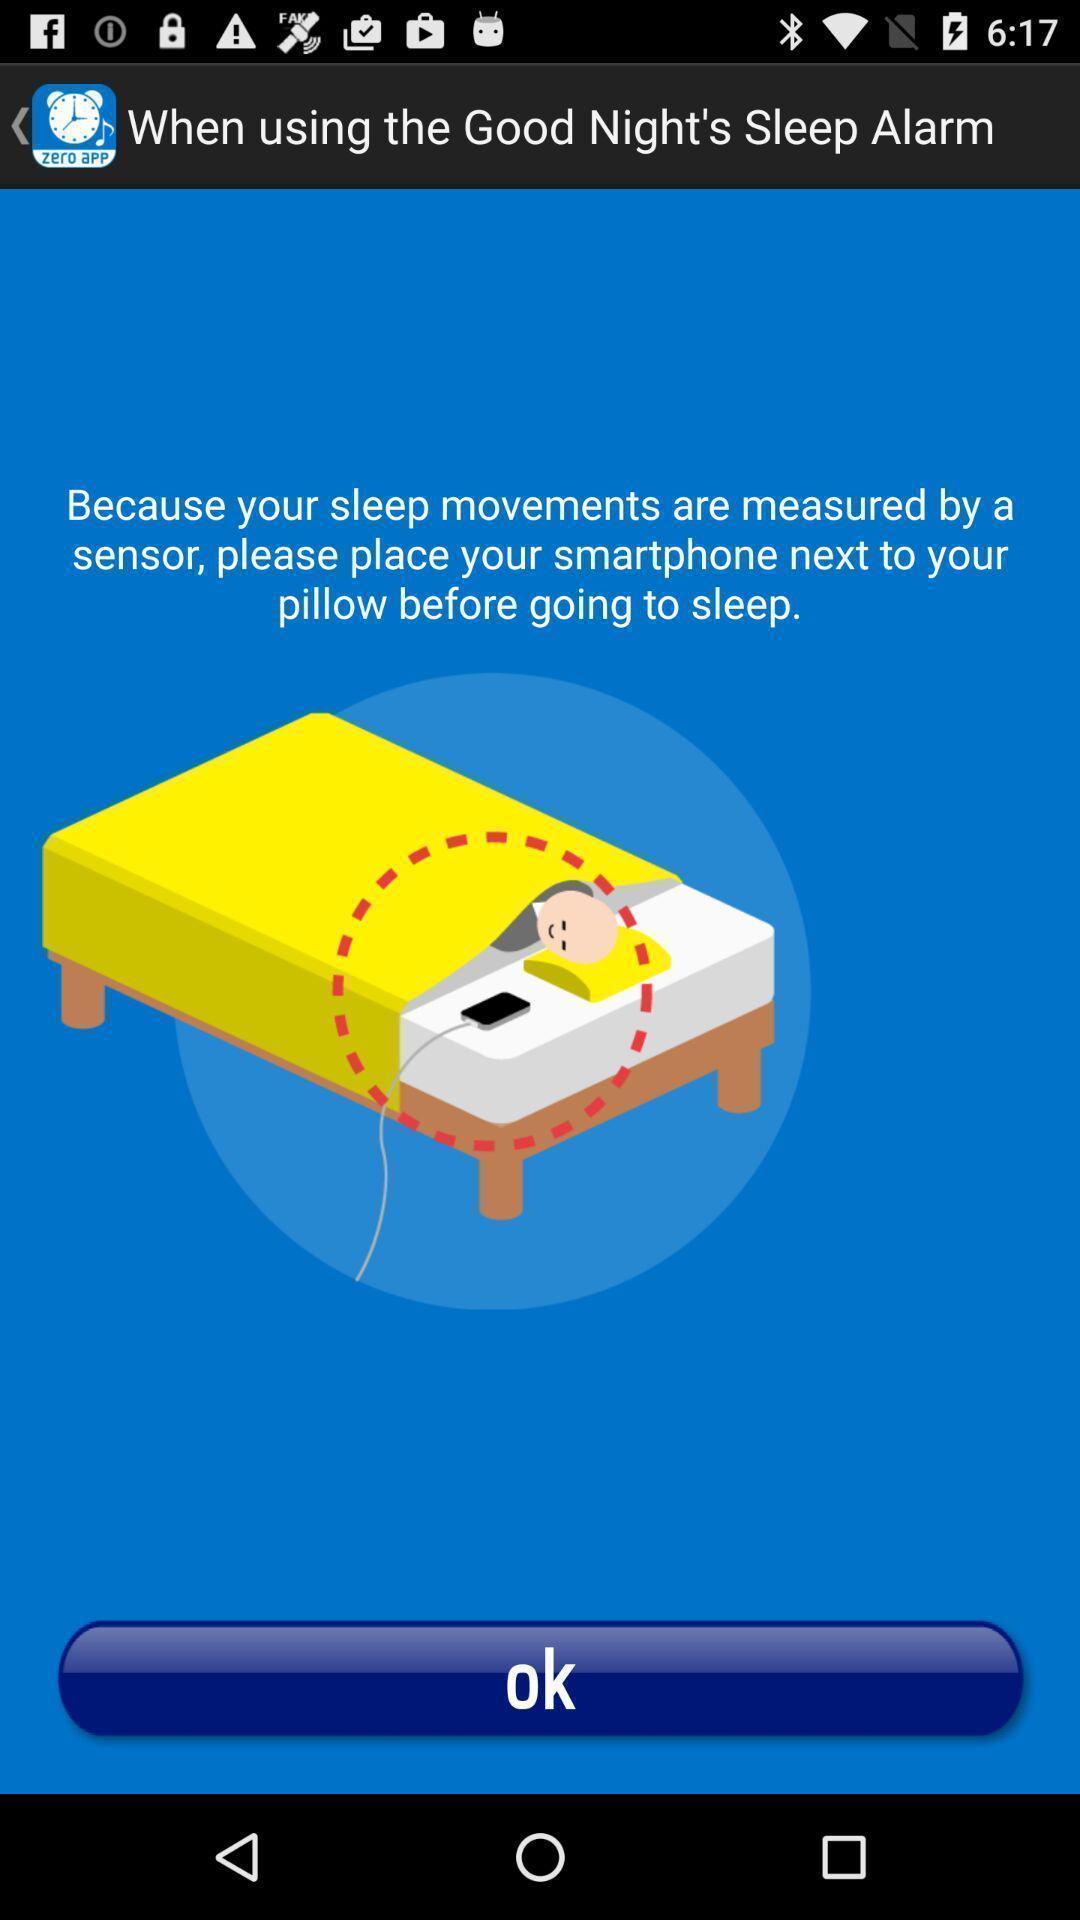Provide a description of this screenshot. Page showing the tutorial. 